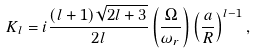<formula> <loc_0><loc_0><loc_500><loc_500>K _ { l } = i \frac { ( l + 1 ) \sqrt { 2 l + 3 } } { 2 l } \left ( \frac { \Omega } { \omega _ { r } } \right ) \left ( \frac { a } { R } \right ) ^ { l - 1 } ,</formula> 